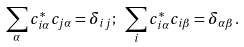<formula> <loc_0><loc_0><loc_500><loc_500>\sum _ { \alpha } c _ { i \alpha } ^ { * } c _ { j \alpha } = \delta _ { i j } ; \ \sum _ { i } c _ { i \alpha } ^ { * } c _ { i \beta } = \delta _ { \alpha \beta } .</formula> 